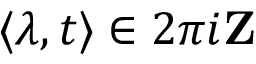Convert formula to latex. <formula><loc_0><loc_0><loc_500><loc_500>\langle \lambda , t \rangle \in 2 \pi i Z</formula> 